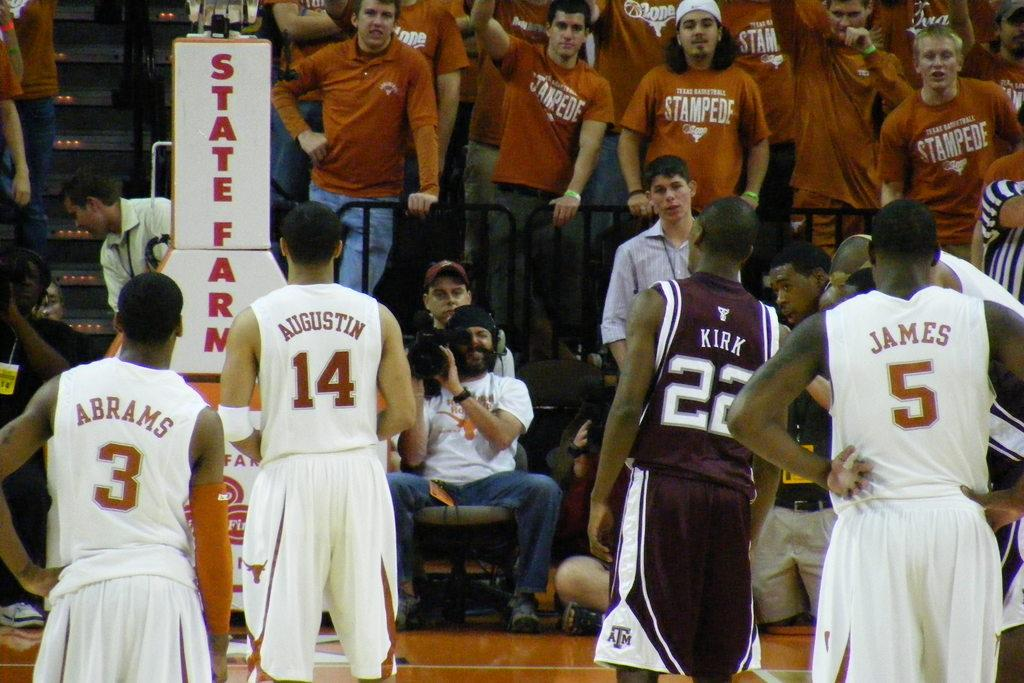<image>
Create a compact narrative representing the image presented. two basketball teams with fans wearing orange to support texas basketball 